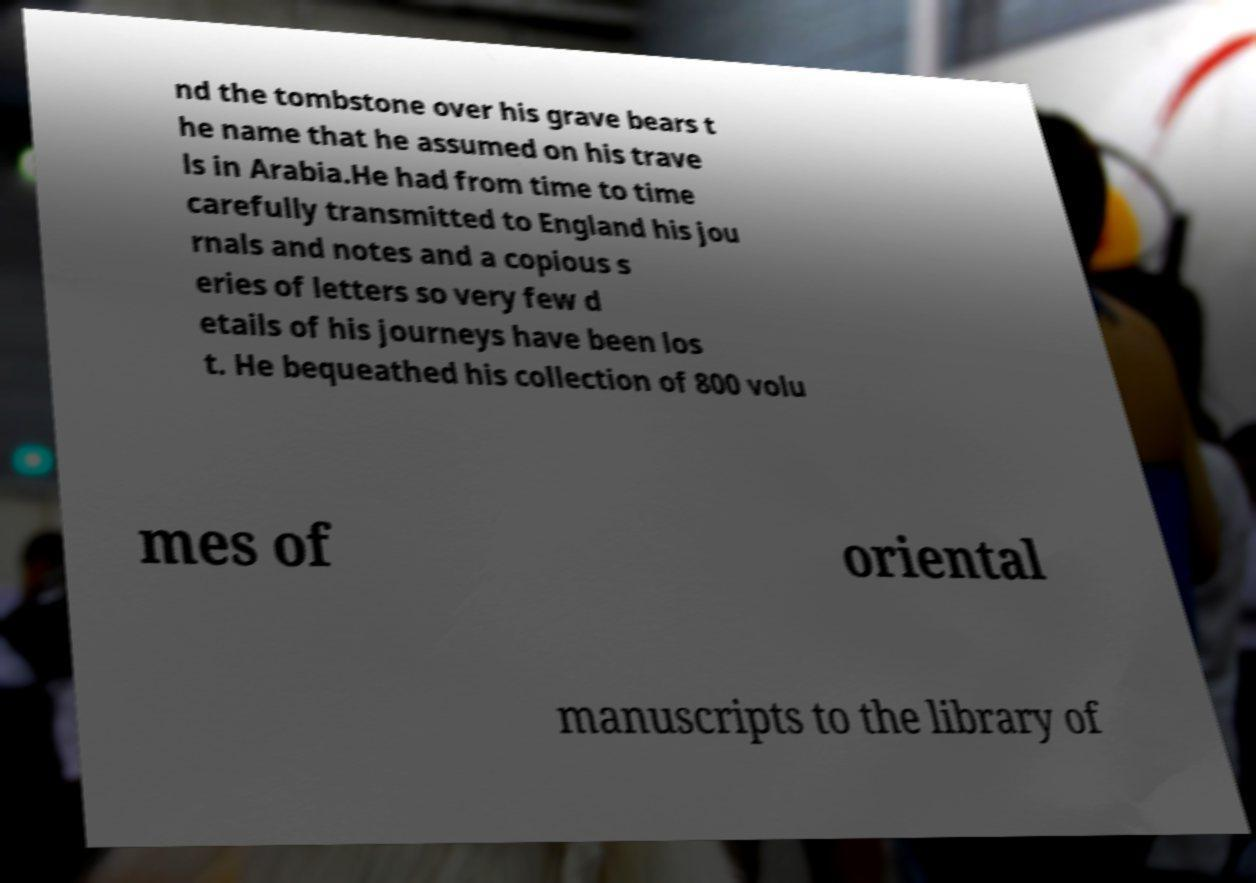Could you extract and type out the text from this image? nd the tombstone over his grave bears t he name that he assumed on his trave ls in Arabia.He had from time to time carefully transmitted to England his jou rnals and notes and a copious s eries of letters so very few d etails of his journeys have been los t. He bequeathed his collection of 800 volu mes of oriental manuscripts to the library of 